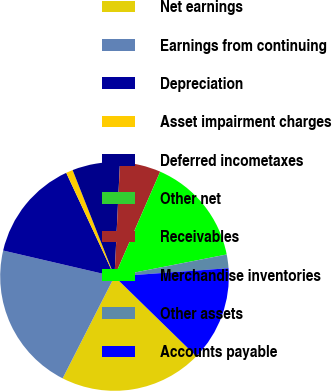<chart> <loc_0><loc_0><loc_500><loc_500><pie_chart><fcel>Net earnings<fcel>Earnings from continuing<fcel>Depreciation<fcel>Asset impairment charges<fcel>Deferred incometaxes<fcel>Other net<fcel>Receivables<fcel>Merchandise inventories<fcel>Other assets<fcel>Accounts payable<nl><fcel>20.19%<fcel>21.15%<fcel>14.42%<fcel>0.97%<fcel>6.73%<fcel>0.01%<fcel>5.77%<fcel>15.38%<fcel>1.93%<fcel>13.46%<nl></chart> 